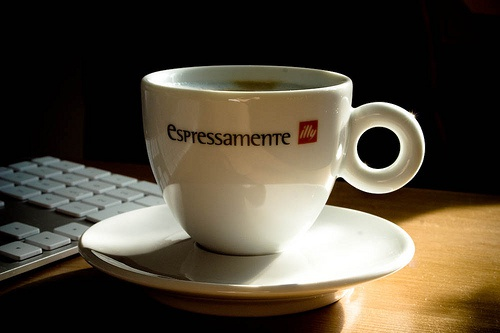Describe the objects in this image and their specific colors. I can see cup in black, gray, tan, and ivory tones and keyboard in black, gray, and darkgray tones in this image. 